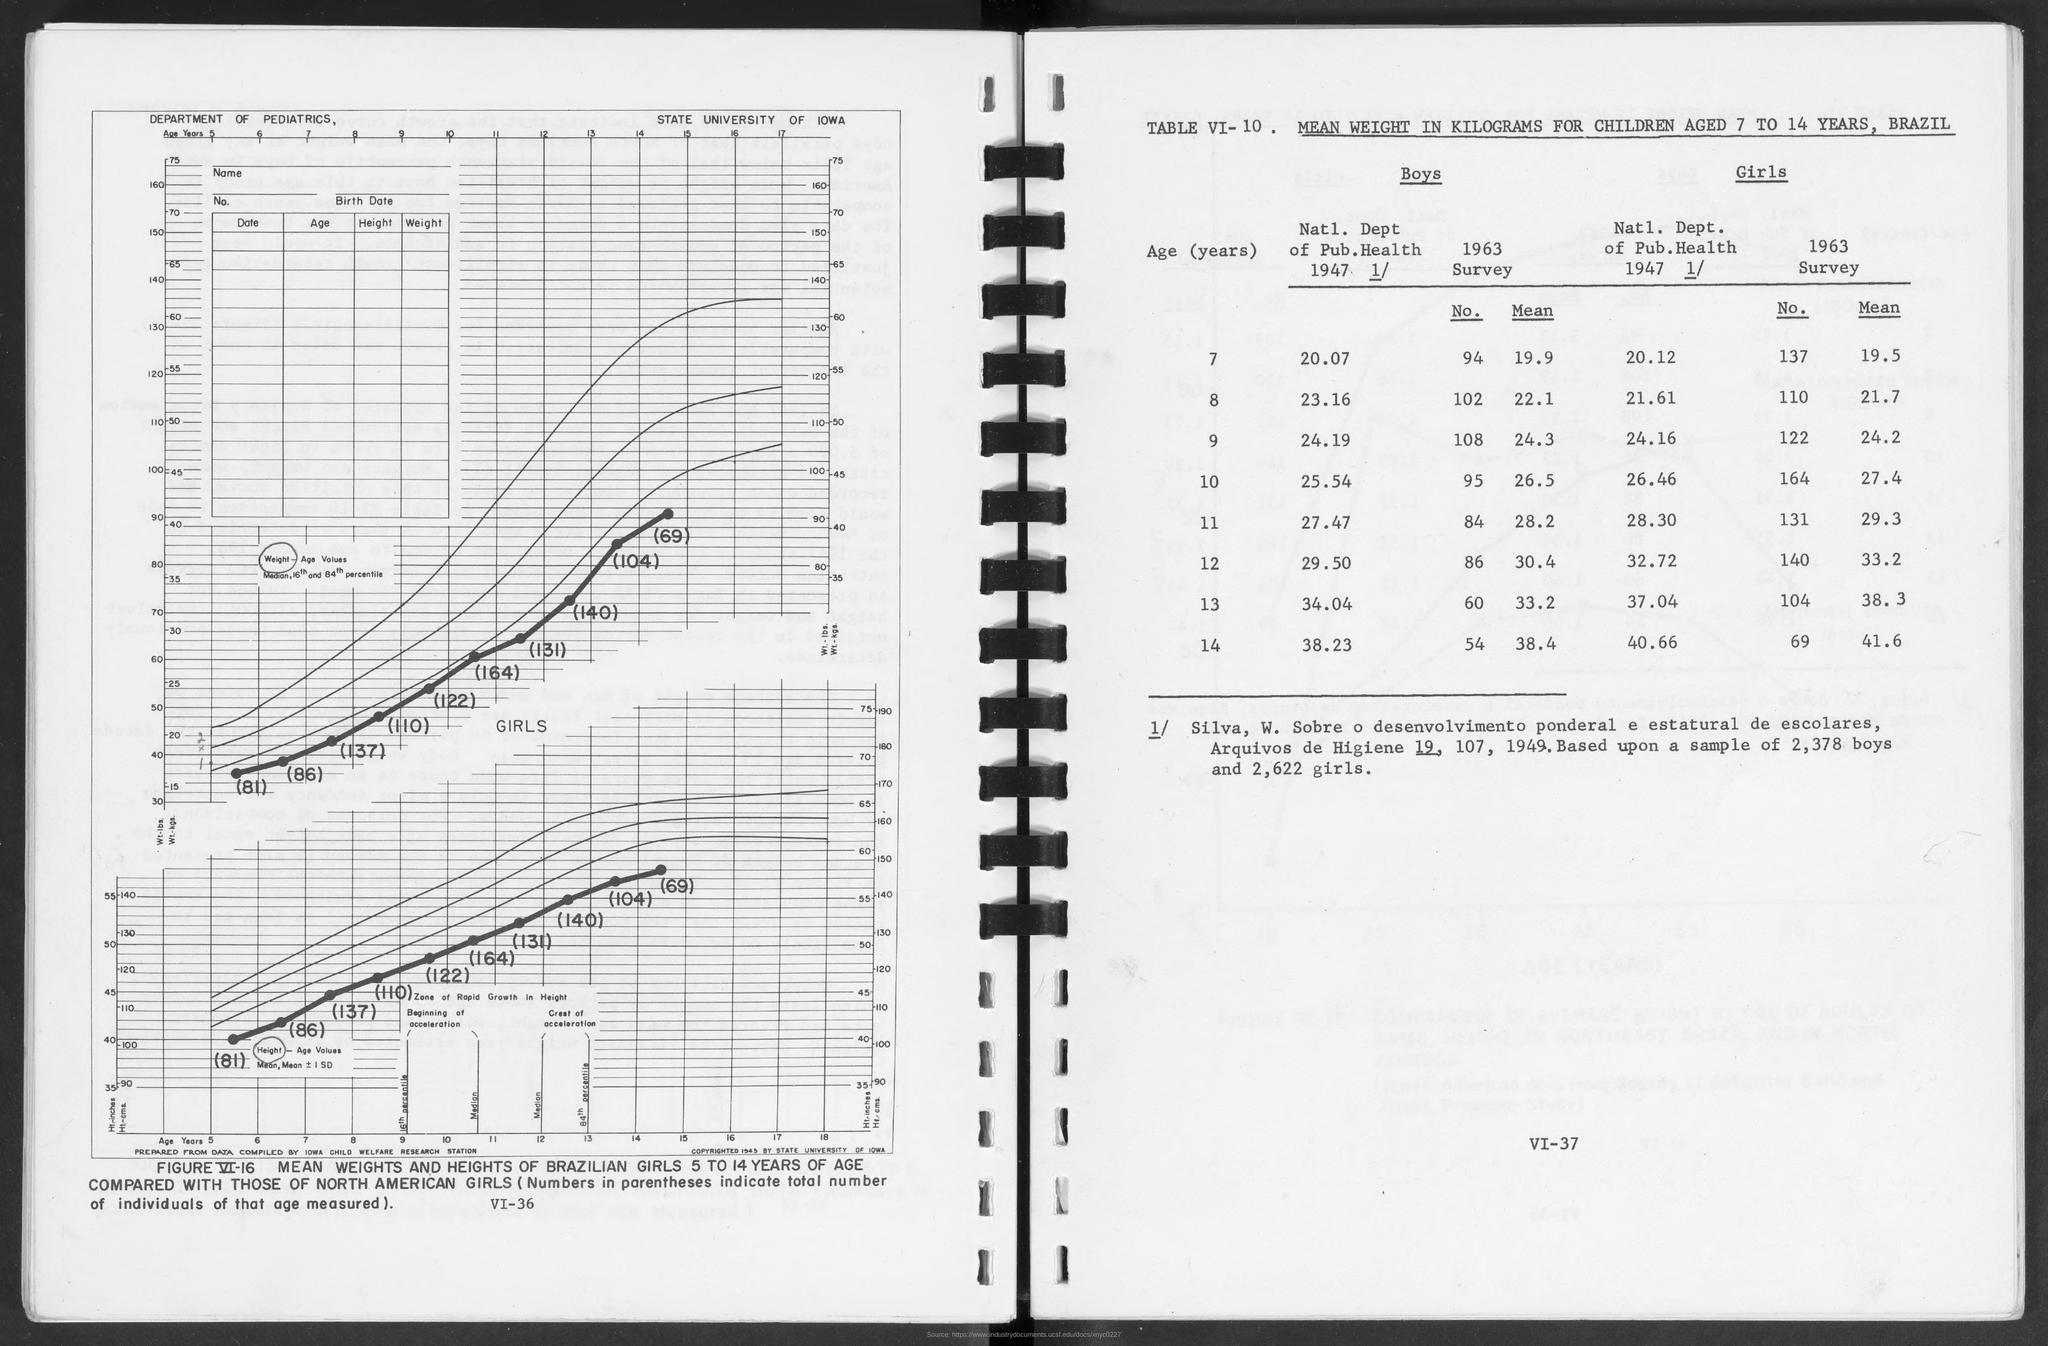List a handful of essential elements in this visual. Table VI-10, titled "MEAN WEIGHT IN KILOGRAMS FOR CHILDREN AGED 7 TO 14 YEARS, BRAZIL," provides a comprehensive overview of the average weight for children in Brazil between the ages of 7 and 14. The Department of Pediatrics has developed the study. The State University of Iowa is mentioned. 